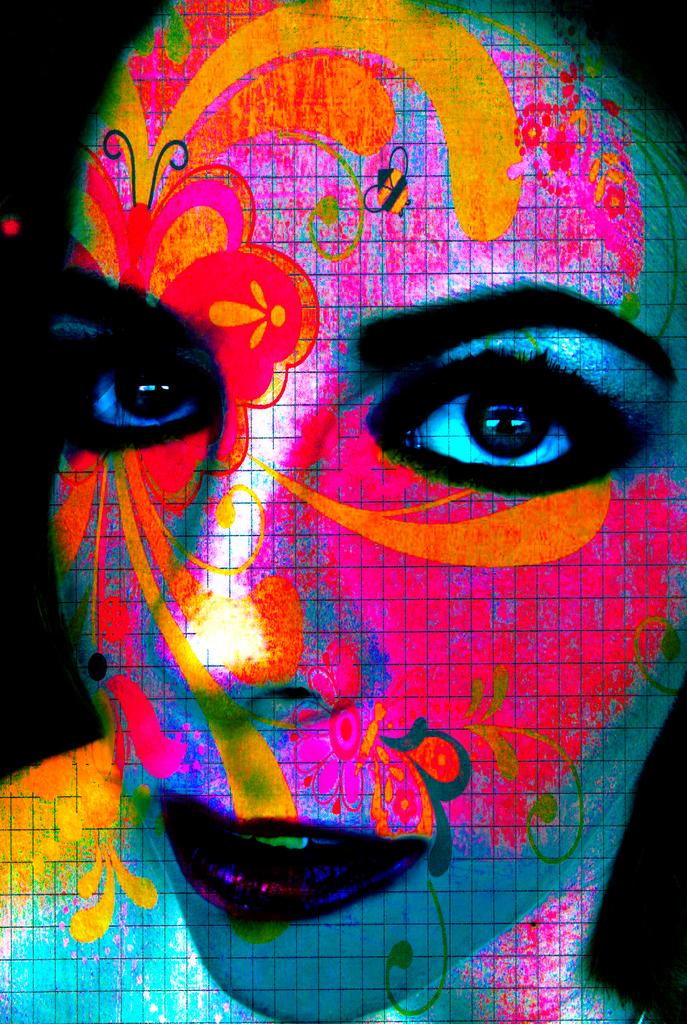What is on the woman's face in the image? There is a painting on the woman's face in the image. What type of space-themed banana can be seen in the mailbox in the image? There is no space-themed banana or mailbox present in the image; it features a painting on a woman's face. 